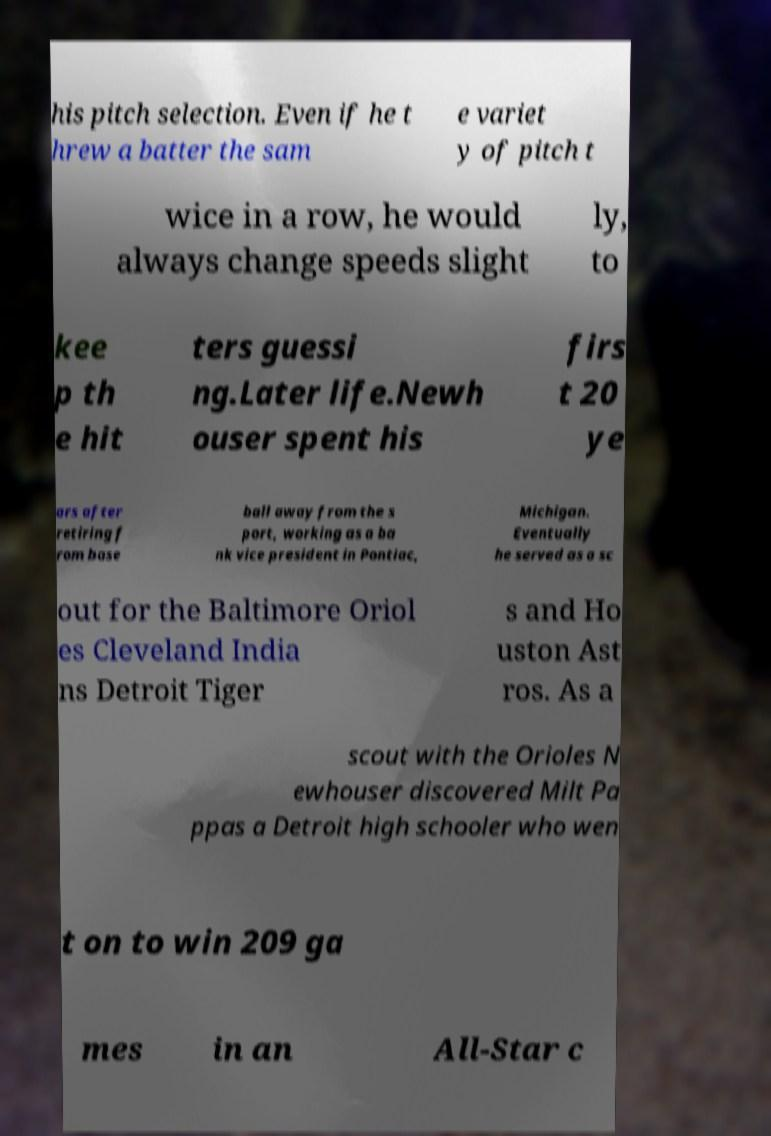Could you extract and type out the text from this image? his pitch selection. Even if he t hrew a batter the sam e variet y of pitch t wice in a row, he would always change speeds slight ly, to kee p th e hit ters guessi ng.Later life.Newh ouser spent his firs t 20 ye ars after retiring f rom base ball away from the s port, working as a ba nk vice president in Pontiac, Michigan. Eventually he served as a sc out for the Baltimore Oriol es Cleveland India ns Detroit Tiger s and Ho uston Ast ros. As a scout with the Orioles N ewhouser discovered Milt Pa ppas a Detroit high schooler who wen t on to win 209 ga mes in an All-Star c 